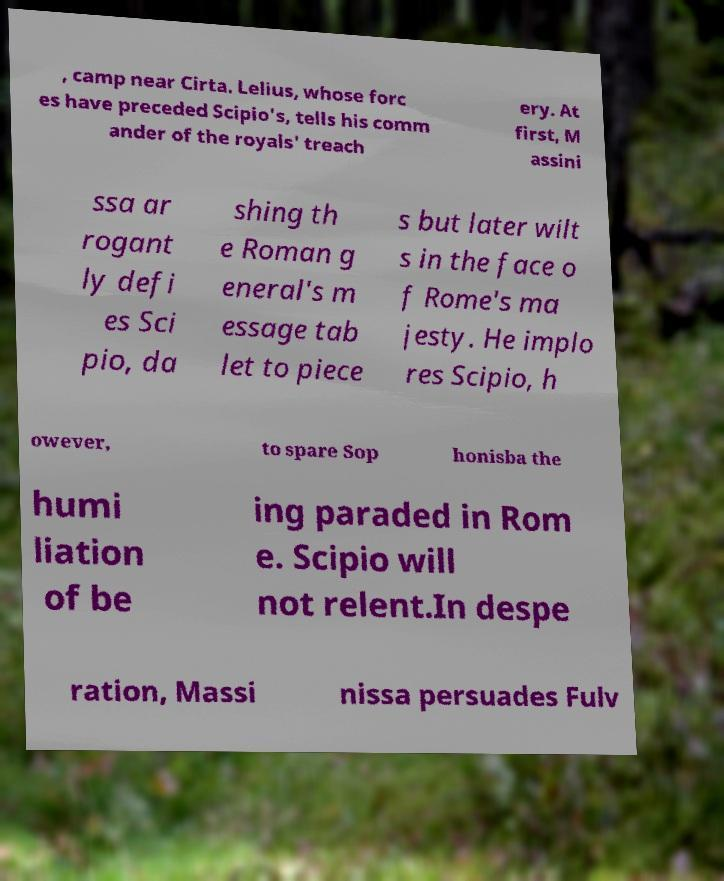Could you extract and type out the text from this image? , camp near Cirta. Lelius, whose forc es have preceded Scipio's, tells his comm ander of the royals' treach ery. At first, M assini ssa ar rogant ly defi es Sci pio, da shing th e Roman g eneral's m essage tab let to piece s but later wilt s in the face o f Rome's ma jesty. He implo res Scipio, h owever, to spare Sop honisba the humi liation of be ing paraded in Rom e. Scipio will not relent.In despe ration, Massi nissa persuades Fulv 